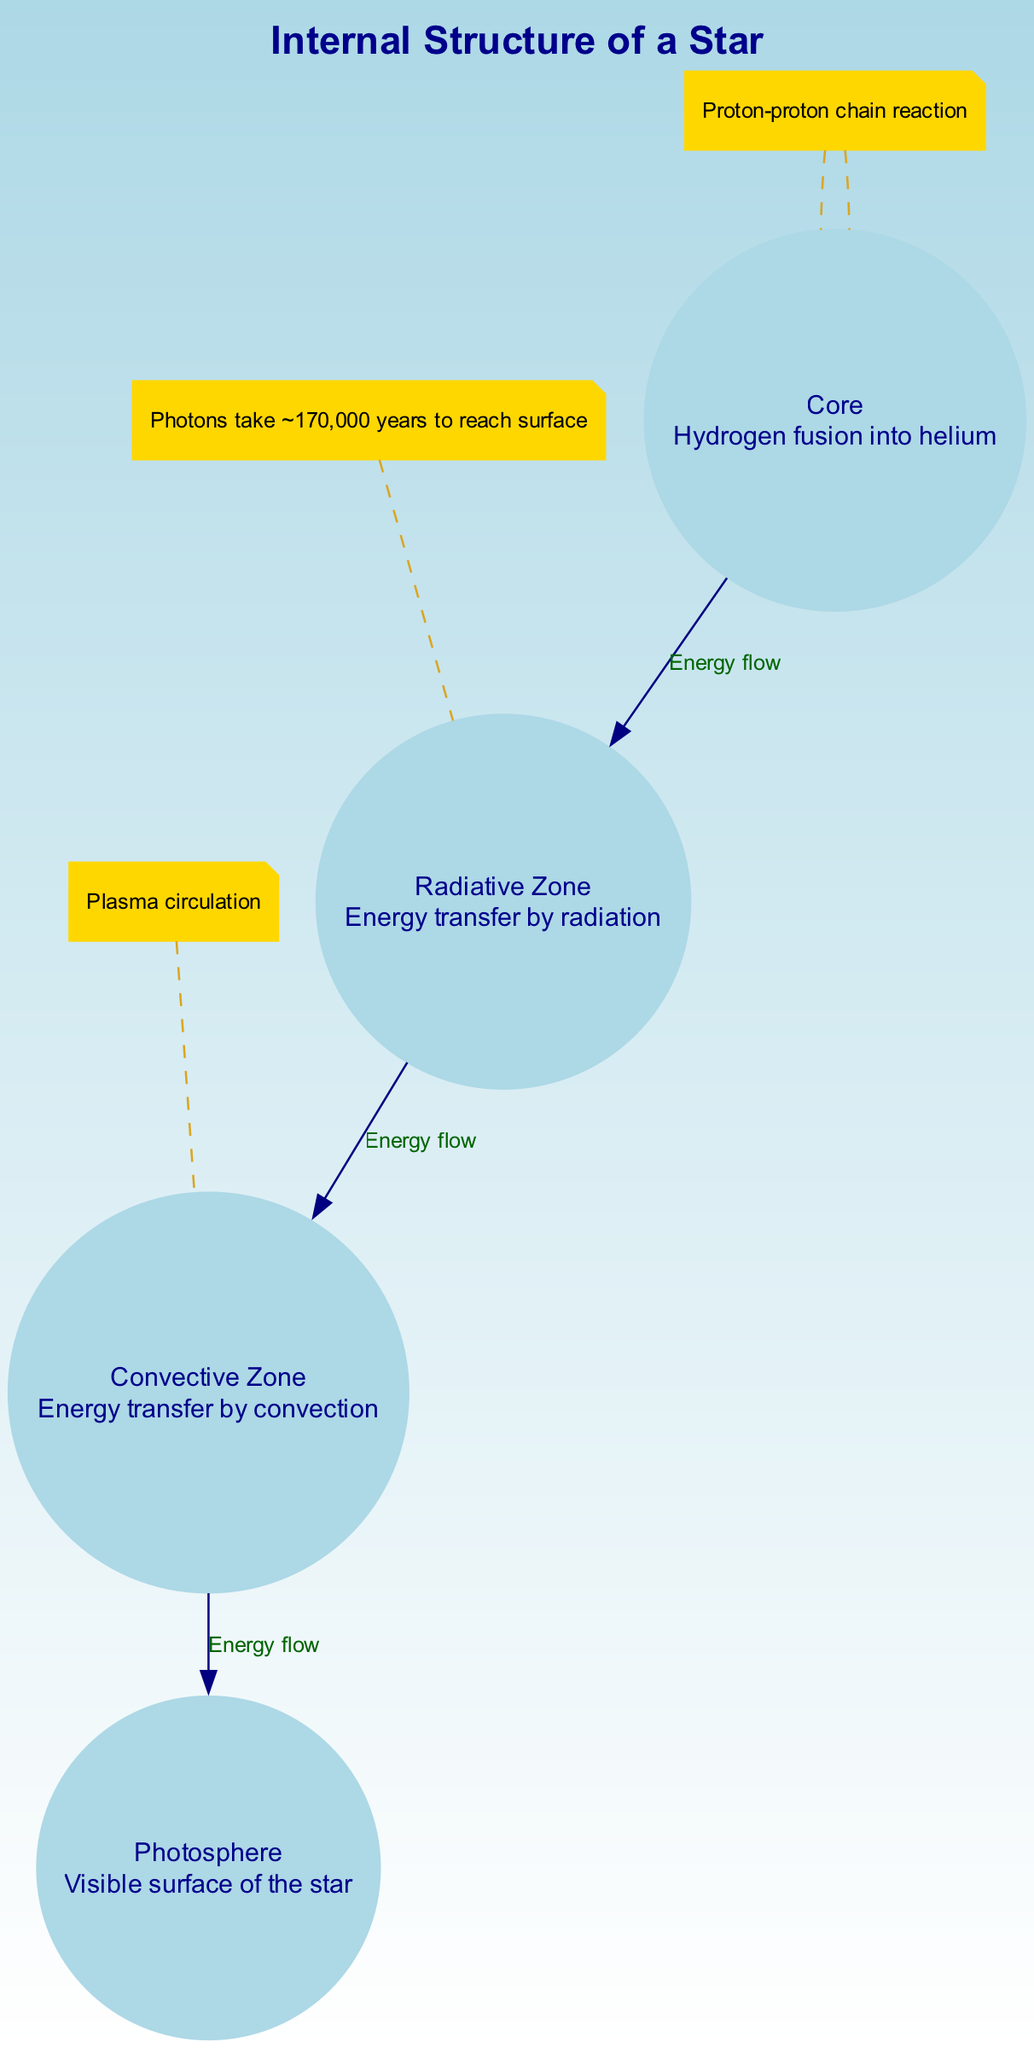What is the primary fusion process occurring in the core? The core of the star is described with the text "Hydrogen fusion into helium," indicating that this is the primary fusion process present there.
Answer: Hydrogen fusion into helium What energy transfer method is employed in the radiative zone? The diagram specifies that the radiative zone utilizes "Energy transfer by radiation," which clearly indicates the method of energy transfer in this region.
Answer: Energy transfer by radiation How many nodes are present in the diagram? The nodes included in the diagram are the core, radiative zone, convective zone, and photosphere. Counting these gives a total of four nodes.
Answer: 4 What is the temperature range at the core? The annotation in the diagram specifically states "Temperature: ~15 million K," which provides the answer to the temperature range in the core.
Answer: ~15 million K What flow direction is indicated between the convective zone and the photosphere? The edge labeled "Energy flow" between the convective zone and the photosphere shows the direction of energy transfer, indicating that energy flows from the convective zone to the photosphere.
Answer: Energy flow What type of reaction occurs in the core? The text annotation in the core section mentions "Proton-proton chain reaction," which is essential to identify the specific type of reaction taking place there.
Answer: Proton-proton chain reaction What phenomenon describes energy transfer in the convective zone? The annotation under the convective zone states "Plasma circulation," which defines the energy transfer phenomenon occurring in this layer of the star.
Answer: Plasma circulation How long does it typically take for photons to reach the surface from the radiative zone? According to the annotation, "Photons take ~170,000 years to reach surface," clearly indicating the time it takes for photons to exit the star from this zone.
Answer: ~170,000 years Which zone is visible as the surface of the star? The section labeled "Photosphere" describes it as the "Visible surface of the star," which directly identifies this layer as the outermost part seen.
Answer: Photosphere 